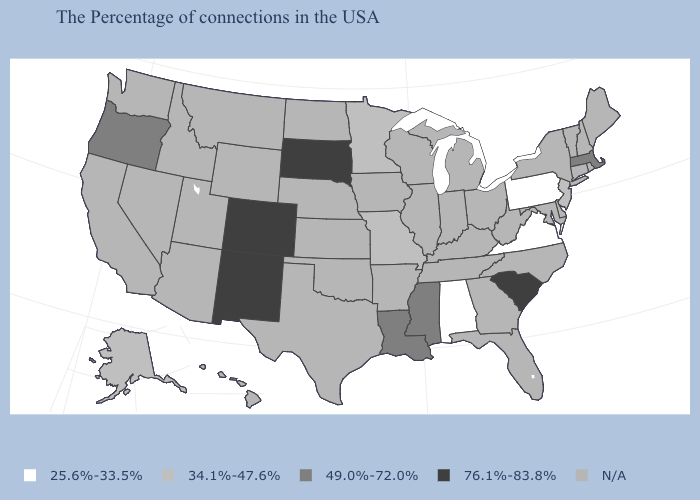What is the value of Nebraska?
Be succinct. N/A. Name the states that have a value in the range N/A?
Short answer required. Maine, Rhode Island, New Hampshire, Vermont, Connecticut, New York, Delaware, Maryland, North Carolina, West Virginia, Ohio, Florida, Georgia, Michigan, Kentucky, Indiana, Tennessee, Wisconsin, Illinois, Arkansas, Iowa, Kansas, Nebraska, Oklahoma, Texas, North Dakota, Wyoming, Utah, Montana, Arizona, Idaho, Nevada, California, Washington, Hawaii. What is the value of Vermont?
Short answer required. N/A. Which states have the highest value in the USA?
Concise answer only. South Carolina, South Dakota, Colorado, New Mexico. Does South Dakota have the highest value in the MidWest?
Be succinct. Yes. Which states have the highest value in the USA?
Answer briefly. South Carolina, South Dakota, Colorado, New Mexico. Does Alaska have the lowest value in the USA?
Quick response, please. No. Among the states that border Georgia , which have the lowest value?
Give a very brief answer. Alabama. Name the states that have a value in the range N/A?
Give a very brief answer. Maine, Rhode Island, New Hampshire, Vermont, Connecticut, New York, Delaware, Maryland, North Carolina, West Virginia, Ohio, Florida, Georgia, Michigan, Kentucky, Indiana, Tennessee, Wisconsin, Illinois, Arkansas, Iowa, Kansas, Nebraska, Oklahoma, Texas, North Dakota, Wyoming, Utah, Montana, Arizona, Idaho, Nevada, California, Washington, Hawaii. What is the value of North Carolina?
Answer briefly. N/A. What is the value of California?
Give a very brief answer. N/A. Does Alaska have the lowest value in the West?
Short answer required. Yes. Among the states that border Iowa , which have the lowest value?
Quick response, please. Missouri, Minnesota. What is the value of Nevada?
Be succinct. N/A. What is the value of Kentucky?
Keep it brief. N/A. 